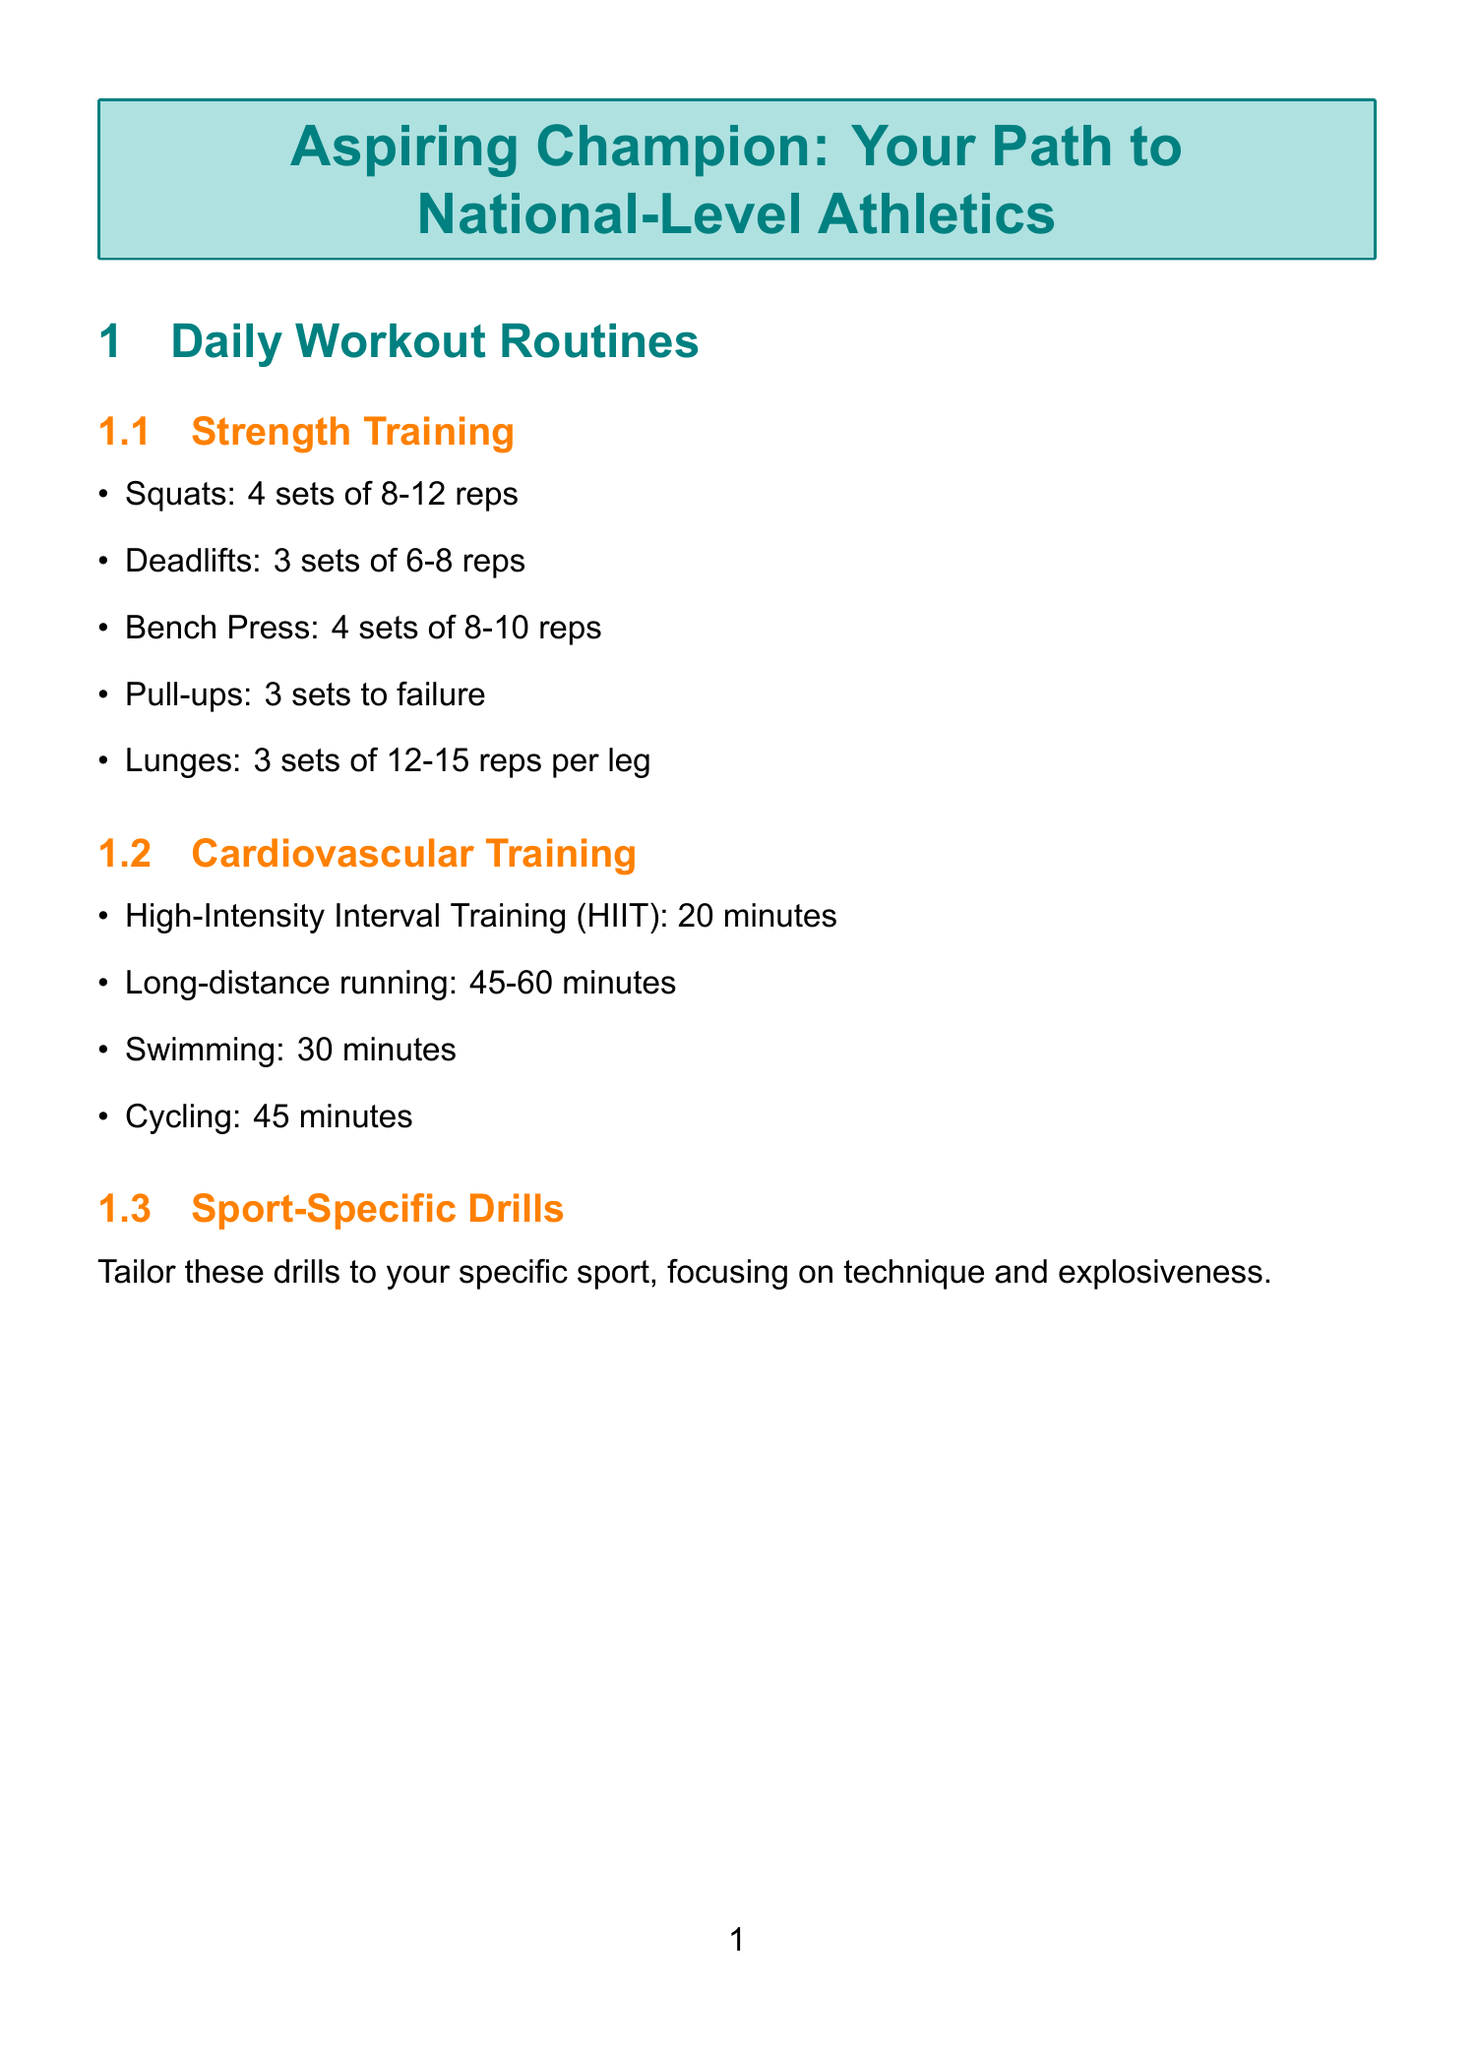What exercises are included in strength training? The strength training exercises listed in the document are squats, deadlifts, bench press, pull-ups, and lunges.
Answer: Squats, deadlifts, bench press, pull-ups, lunges How many sets of deadlifts should be performed? The document specifies that deadlifts should be performed for 3 sets of 6-8 reps.
Answer: 3 sets of 6-8 reps What is the recommended sleep duration for recovery? The document states that aiming for 8-10 hours of quality sleep per night is essential for recovery.
Answer: 8-10 hours What tool is recommended for tracking daily activity? The Fitbit Charge 5 is mentioned as a tool for tracking daily activity, heart rate, and sleep patterns.
Answer: Fitbit Charge 5 Which technique is suggested for active recovery? The document mentions engaging in light activities like yoga or swimming on rest days as a method of active recovery.
Answer: Yoga or swimming What does the acronym SMART refer to in goal setting? SMART is a concept for establishing goals, but the document does not define the acronym.
Answer: Not defined What is one of the first steps in competition preparation? Researching upcoming national-level competitions and qualification standards is one of the first steps listed in the competition preparation section.
Answer: Research upcoming national-level competitions How long should mindfulness meditation be practiced daily? The document recommends practicing mindfulness meditation for 15 minutes daily.
Answer: 15 minutes 